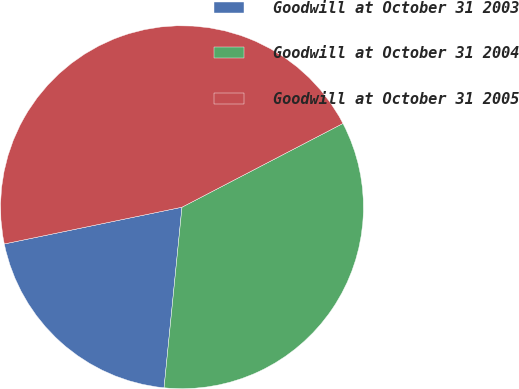Convert chart. <chart><loc_0><loc_0><loc_500><loc_500><pie_chart><fcel>Goodwill at October 31 2003<fcel>Goodwill at October 31 2004<fcel>Goodwill at October 31 2005<nl><fcel>20.18%<fcel>34.21%<fcel>45.61%<nl></chart> 